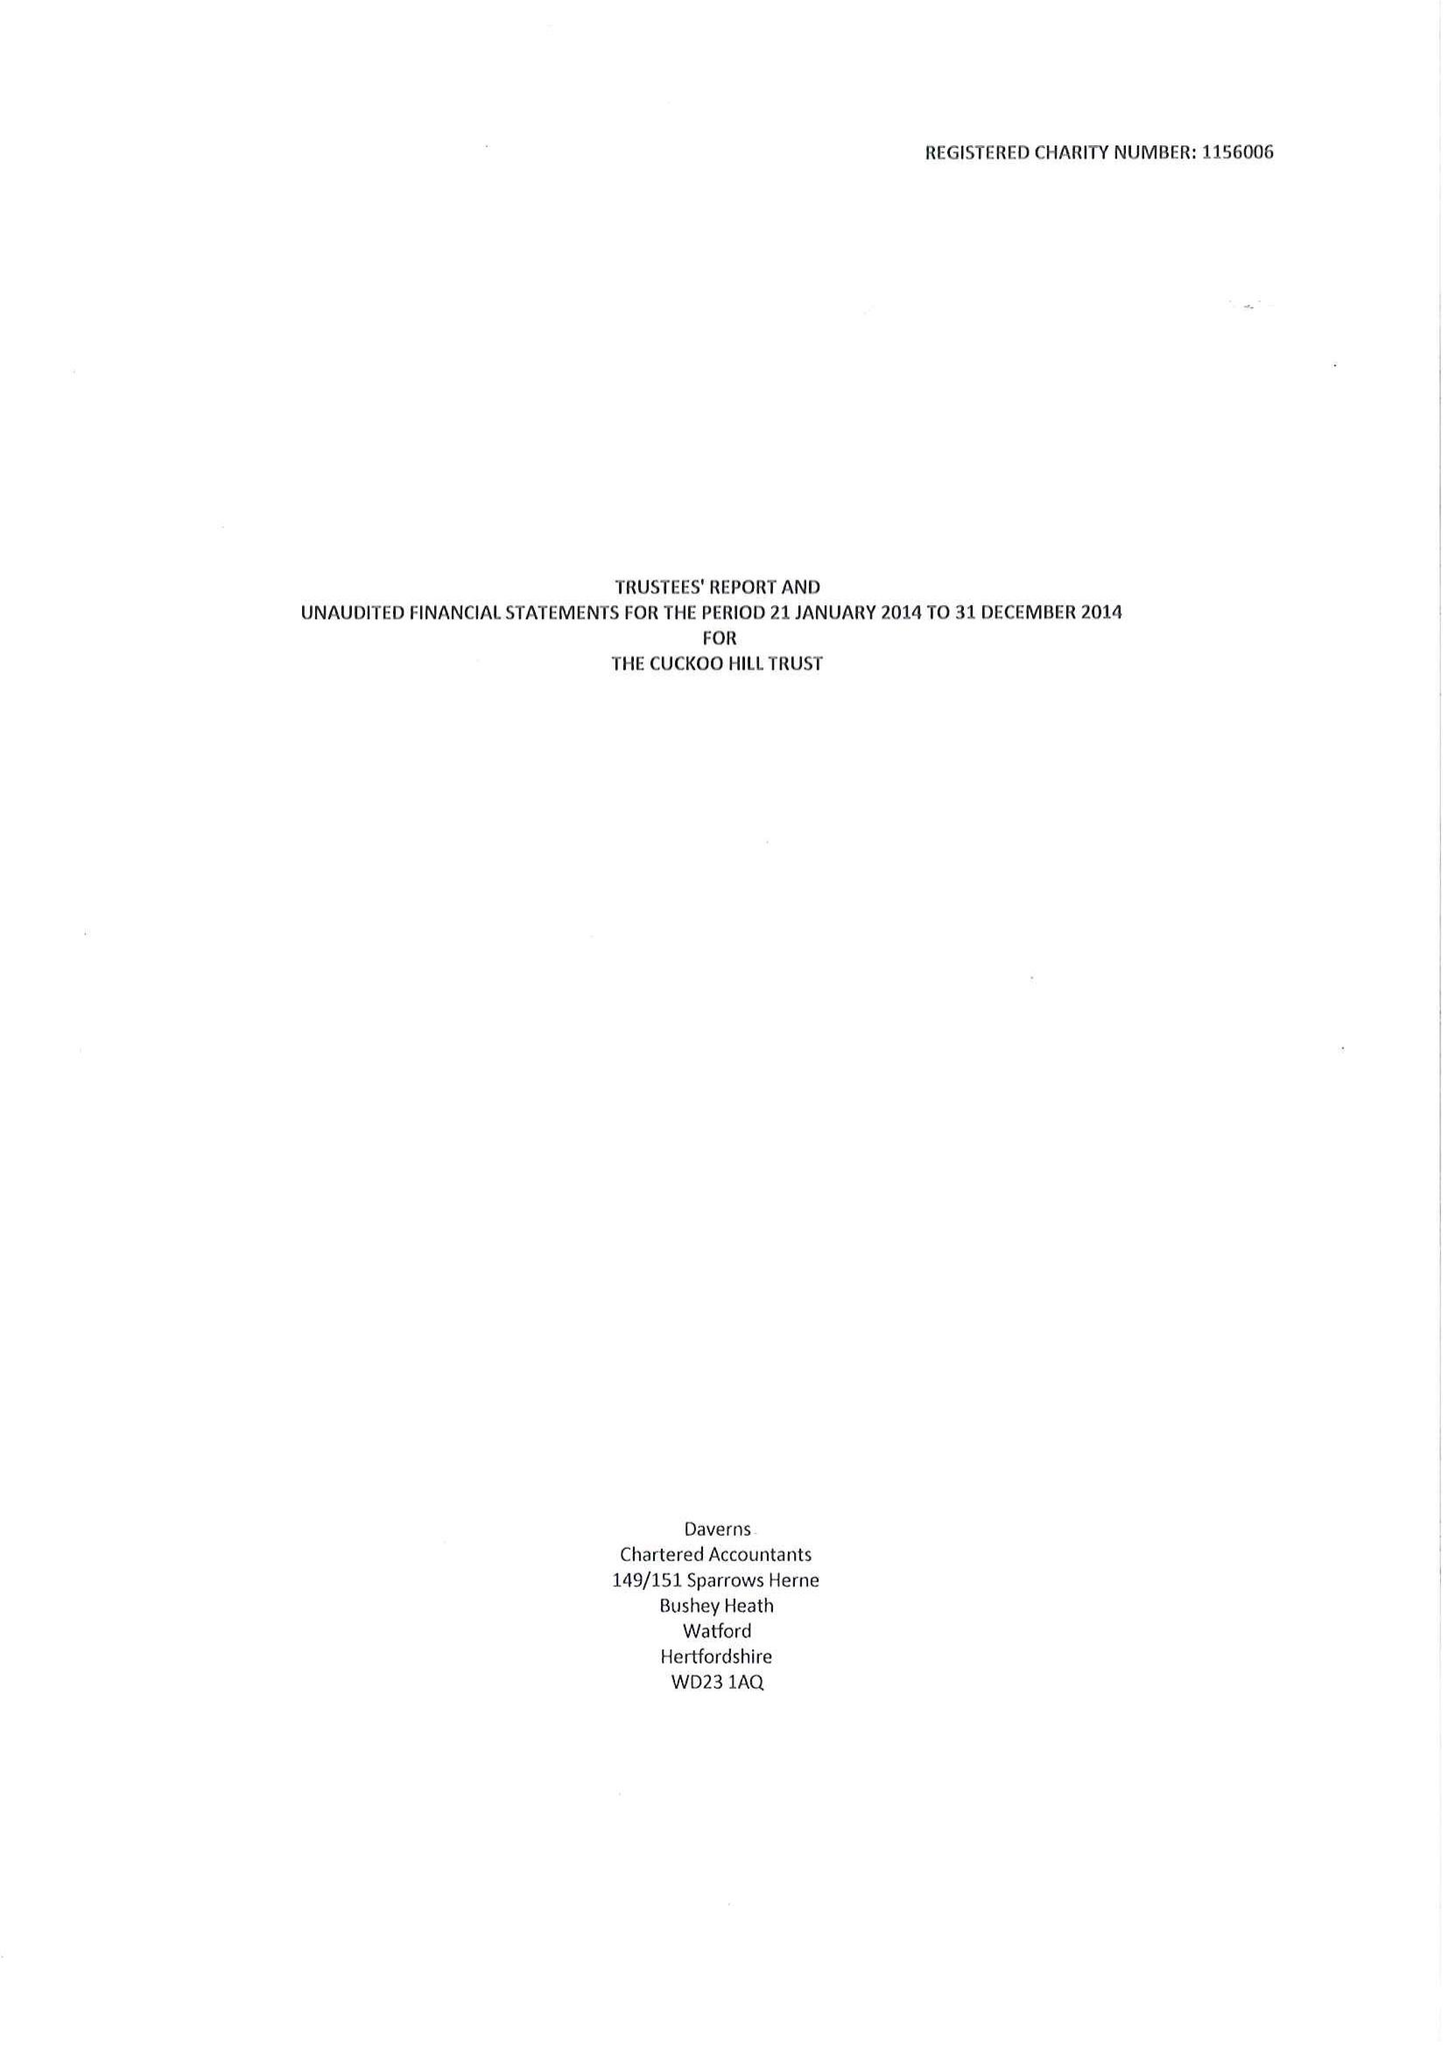What is the value for the address__post_town?
Answer the question using a single word or phrase. PINNER 